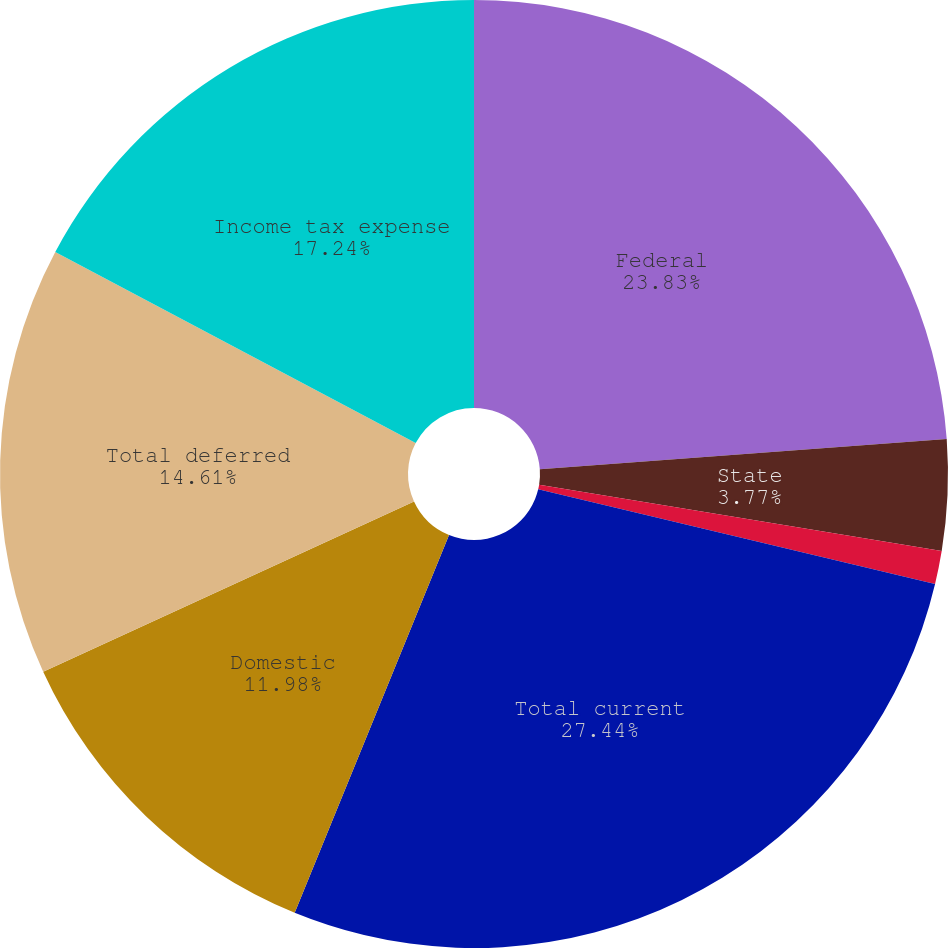Convert chart to OTSL. <chart><loc_0><loc_0><loc_500><loc_500><pie_chart><fcel>Federal<fcel>State<fcel>Foreign<fcel>Total current<fcel>Domestic<fcel>Total deferred<fcel>Income tax expense<nl><fcel>23.83%<fcel>3.77%<fcel>1.13%<fcel>27.45%<fcel>11.98%<fcel>14.61%<fcel>17.24%<nl></chart> 